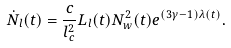Convert formula to latex. <formula><loc_0><loc_0><loc_500><loc_500>\dot { N } _ { l } ( t ) = \frac { c } { l ^ { 2 } _ { c } } L _ { l } ( t ) N ^ { 2 } _ { w } ( t ) e ^ { ( 3 \gamma - 1 ) \lambda ( t ) } .</formula> 